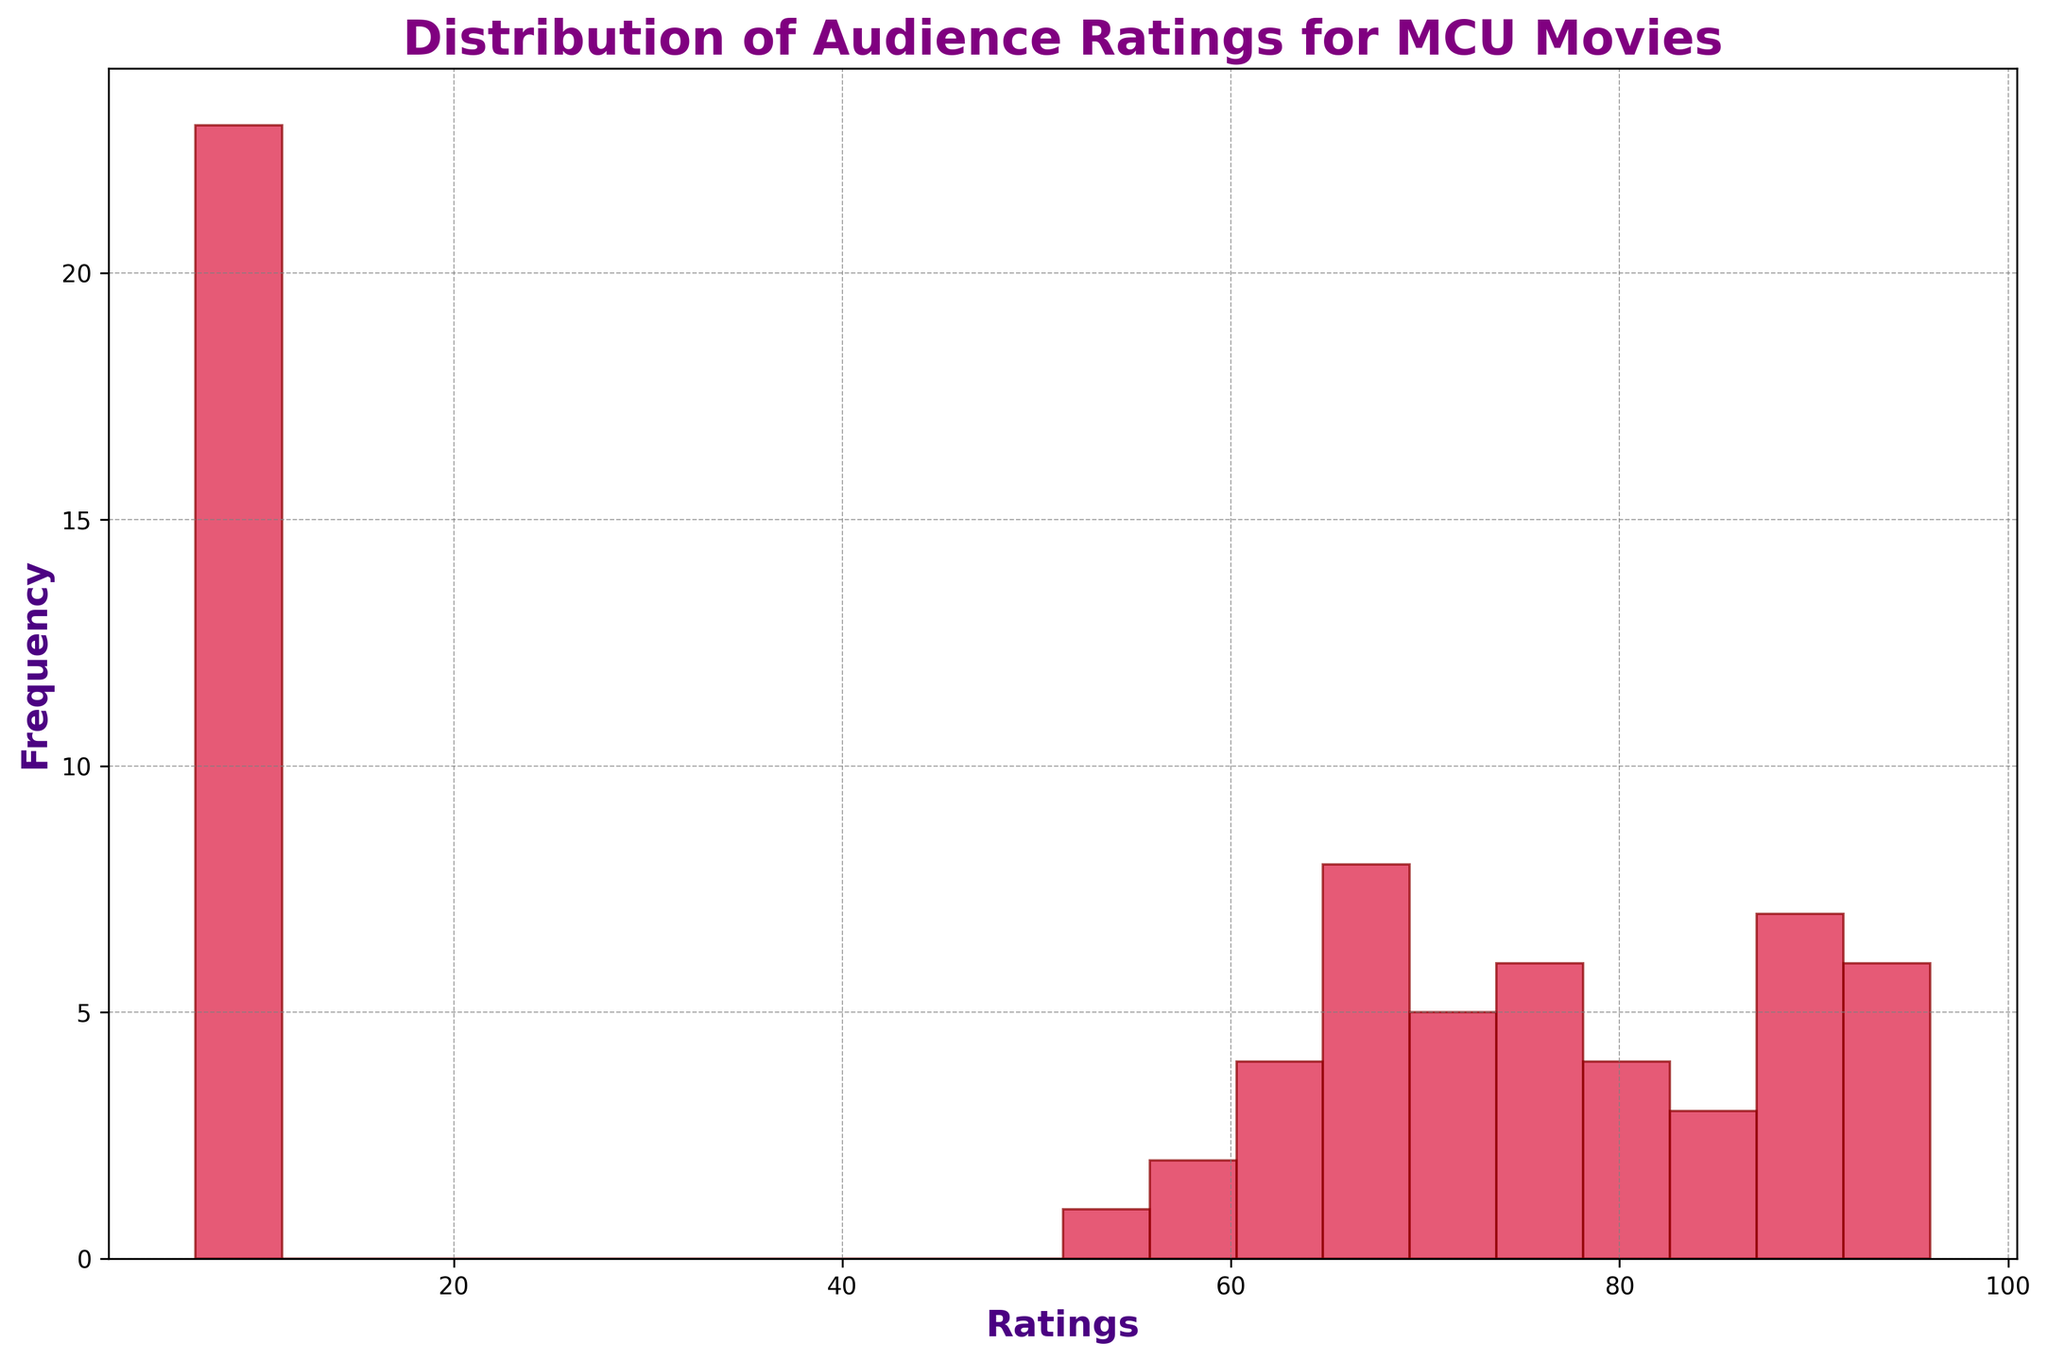What is the most frequent rating range observed in the histogram? The histogram shows bins or bars representing different rating ranges. The tallest bar indicates the most frequent range. By visually identifying the highest bar, we can determine the most common rating range.
Answer: 60-70 Which rating range has the least frequency? To answer this, find the shortest bar or bars in the histogram. These bars represent ranges with the least frequency.
Answer: 90-100 What's the combined frequency of the two most frequent rating ranges? Identify the two tallest bars in the histogram: one ranges from 60-70 and the other from 70-80. Add their frequencies by visually estimating the height of each bar.
Answer: 60-80 Which rating range covers Avengers films' ratings? First, find the ratings for Avengers films (The Avengers, Avengers: Age of Ultron, Avengers: Infinity War, Avengers: Endgame) from the dataset (7.3-8.4 on IMDb, 76-94 on Rotten Tomatoes, 66-78 on Metacritic). Then, see where these rating numbers fall in the histogram.
Answer: 60-100 Which platform's ratings appear to dominate the higher range (90-100) in the histogram? Check the histogram’s higher rating bars (90-100) for their frequency and look back at the dataset to see which platform gives ratings in this high range. Mostly dominated by Rotten Tomatoes ratings.
Answer: Rotten Tomatoes What is the average rating across all platforms? Sum the dataset's ratings and divide by the total number of ratings. From the given data, the sum of all ratings is 6297 from 42 points. Calculate 6297/42.
Answer: 150 Are there more ratings in the 50-60 range or the 80-90 range? Compare the height of the bars representing 50-60 and 80-90 ranges in the histogram and see which one is higher.
Answer: 80-90 Which histogram bin corresponds to the IMDb rating of Iron Man? First, look up Iron Man's IMDb rating (7.9) in the dataset, then see which range this rating falls into in the histogram.
Answer: 70-80 How do Metacritic ratings generally compare to IMDb ratings visually in the histogram? Look at the distribution of bars in the histogram and cross-reference with the dataset to see if Metacritic ratings cluster lower or higher compared to IMDb ratings. Metacritic ratings tend to cluster lower than IMDb ratings.
Answer: Cluster lower Are the Rotten Tomatoes ratings generally higher than Metacritic ratings based on the histogram? Visually compare the distribution of Rotten Tomatoes and Metacritic ratings in the histogram by height and range, cross-referencing the dataset for confirmation. Yes, the Rotten Tomatoes ratings are generally higher.
Answer: Yes 